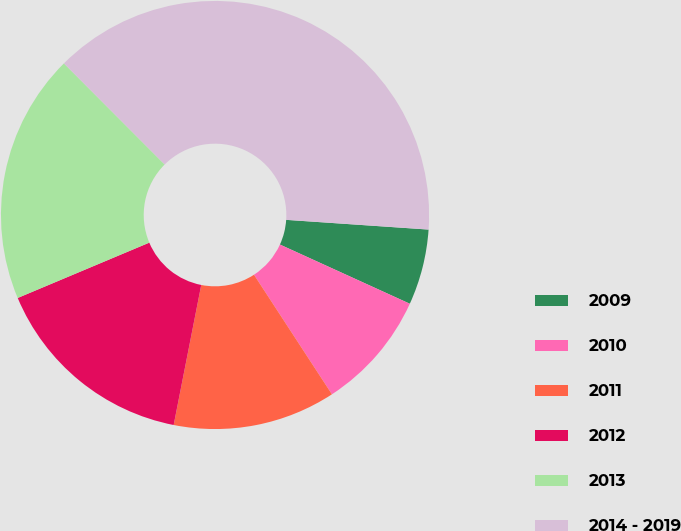Convert chart to OTSL. <chart><loc_0><loc_0><loc_500><loc_500><pie_chart><fcel>2009<fcel>2010<fcel>2011<fcel>2012<fcel>2013<fcel>2014 - 2019<nl><fcel>5.72%<fcel>9.0%<fcel>12.29%<fcel>15.57%<fcel>18.86%<fcel>38.56%<nl></chart> 